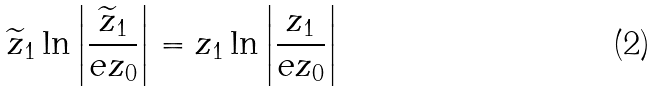Convert formula to latex. <formula><loc_0><loc_0><loc_500><loc_500>\widetilde { z } _ { 1 } \ln \left | \frac { \widetilde { z } _ { 1 } } { e z _ { 0 } } \right | = z _ { 1 } \ln \left | \frac { z _ { 1 } } { e z _ { 0 } } \right |</formula> 